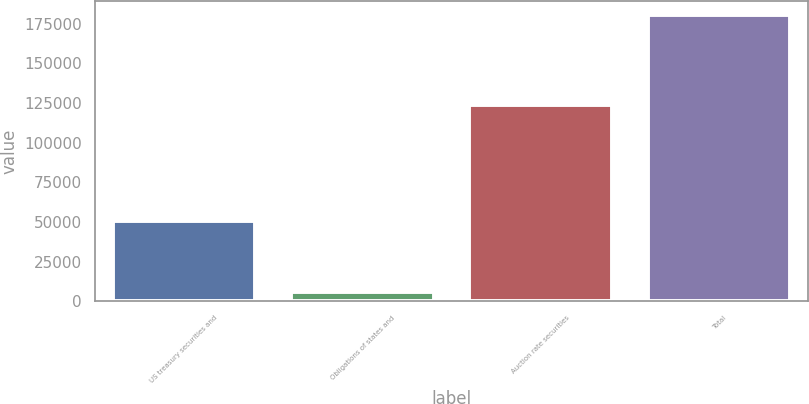Convert chart. <chart><loc_0><loc_0><loc_500><loc_500><bar_chart><fcel>US treasury securities and<fcel>Obligations of states and<fcel>Auction rate securities<fcel>Total<nl><fcel>50400<fcel>6062<fcel>123856<fcel>180318<nl></chart> 